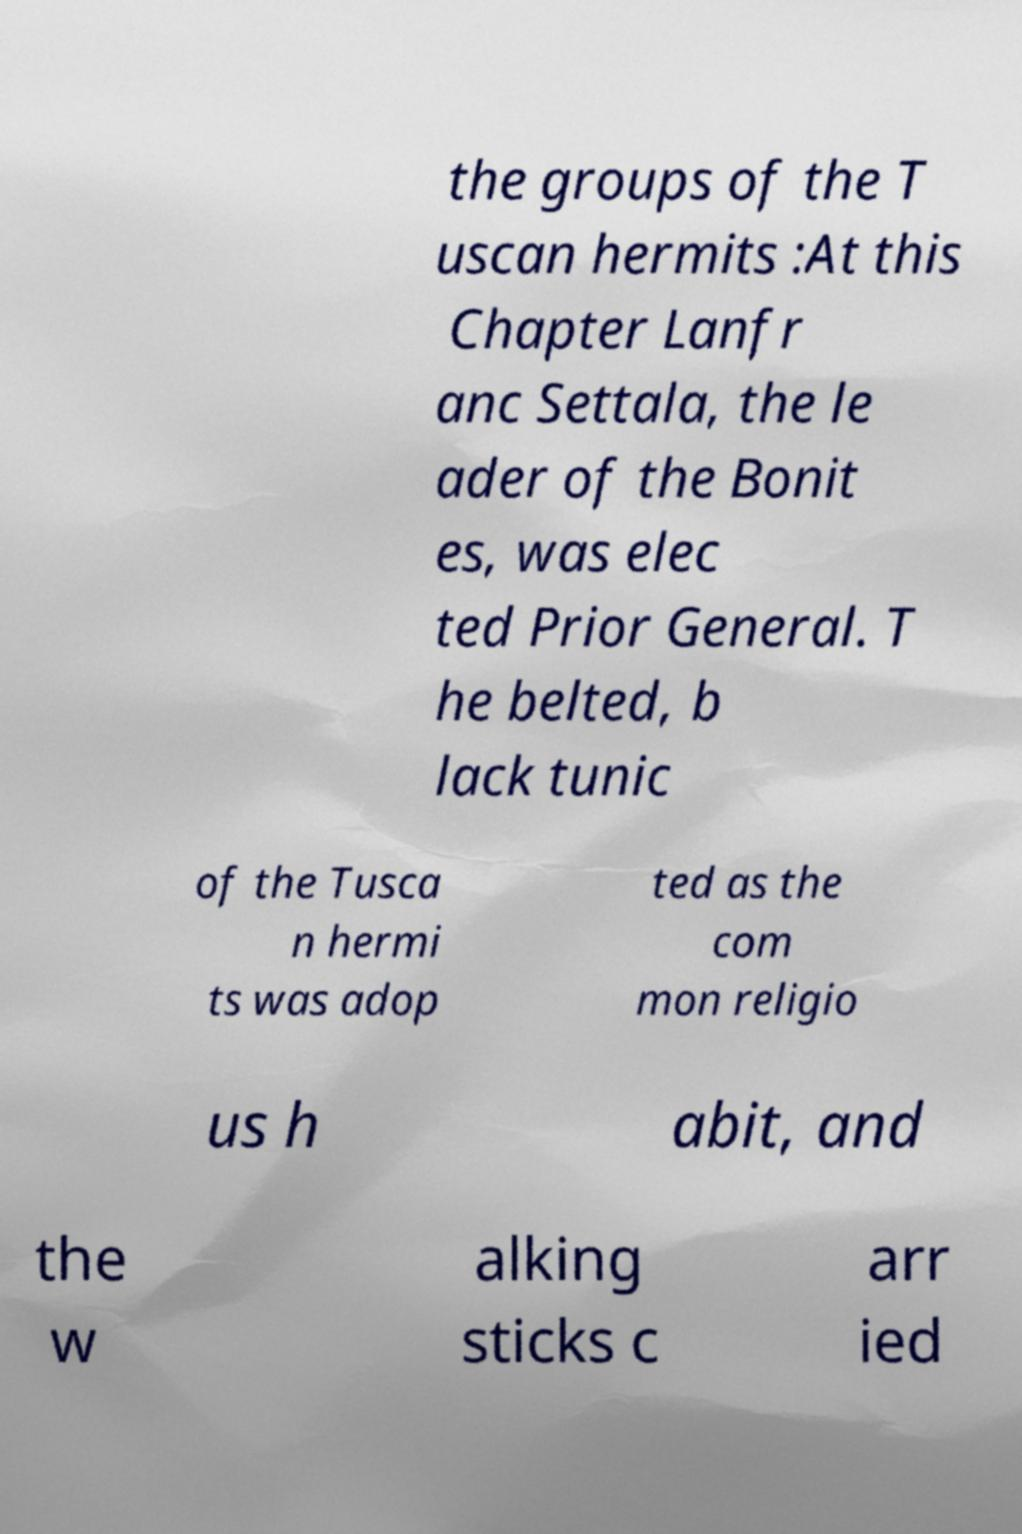Could you extract and type out the text from this image? the groups of the T uscan hermits :At this Chapter Lanfr anc Settala, the le ader of the Bonit es, was elec ted Prior General. T he belted, b lack tunic of the Tusca n hermi ts was adop ted as the com mon religio us h abit, and the w alking sticks c arr ied 